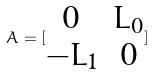<formula> <loc_0><loc_0><loc_500><loc_500>A = [ \begin{matrix} 0 & L _ { 0 } \\ - L _ { 1 } & 0 \end{matrix} ]</formula> 